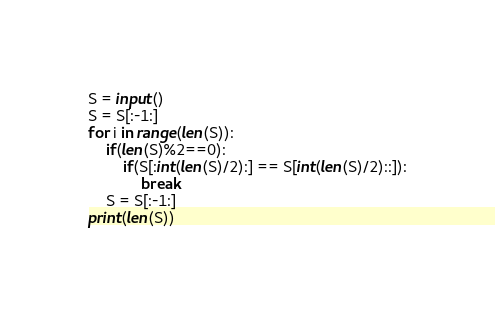Convert code to text. <code><loc_0><loc_0><loc_500><loc_500><_Python_>S = input()
S = S[:-1:]
for i in range(len(S)):
    if(len(S)%2==0):
        if(S[:int(len(S)/2):] == S[int(len(S)/2)::]):
            break
    S = S[:-1:]
print(len(S))</code> 